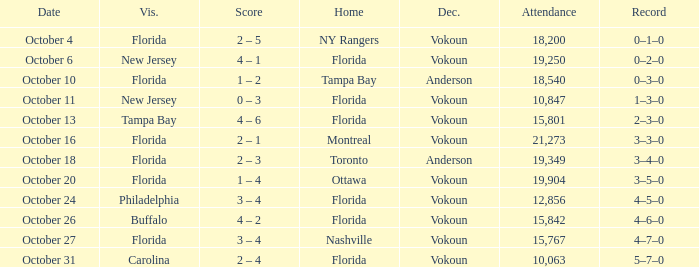Which team was home on October 13? Florida. 